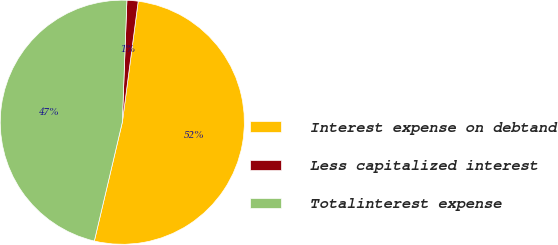Convert chart. <chart><loc_0><loc_0><loc_500><loc_500><pie_chart><fcel>Interest expense on debtand<fcel>Less capitalized interest<fcel>Totalinterest expense<nl><fcel>51.6%<fcel>1.48%<fcel>46.91%<nl></chart> 